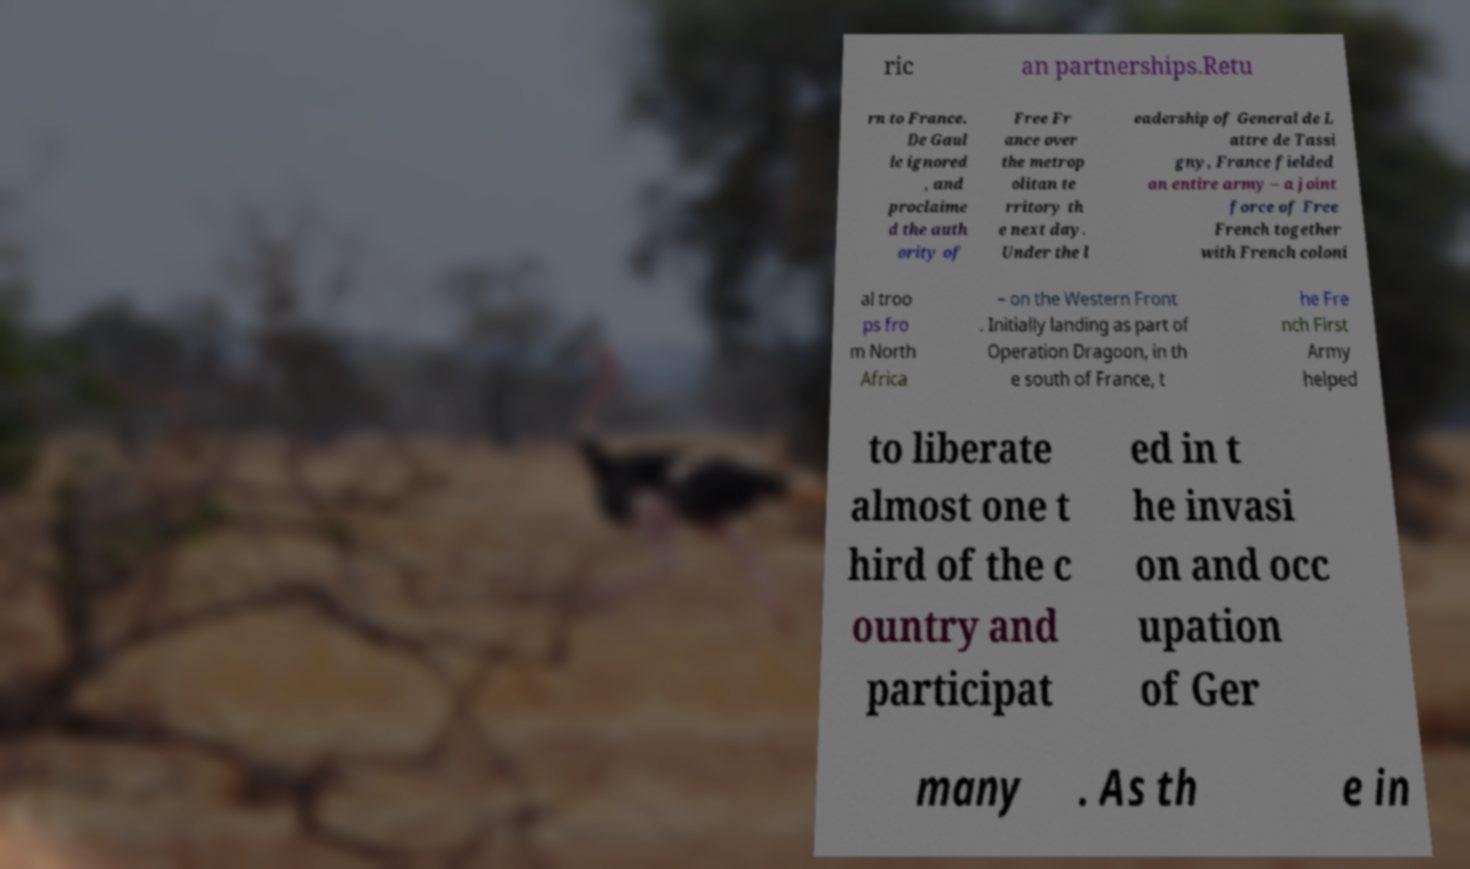Please read and relay the text visible in this image. What does it say? ric an partnerships.Retu rn to France. De Gaul le ignored , and proclaime d the auth ority of Free Fr ance over the metrop olitan te rritory th e next day. Under the l eadership of General de L attre de Tassi gny, France fielded an entire army – a joint force of Free French together with French coloni al troo ps fro m North Africa – on the Western Front . Initially landing as part of Operation Dragoon, in th e south of France, t he Fre nch First Army helped to liberate almost one t hird of the c ountry and participat ed in t he invasi on and occ upation of Ger many . As th e in 